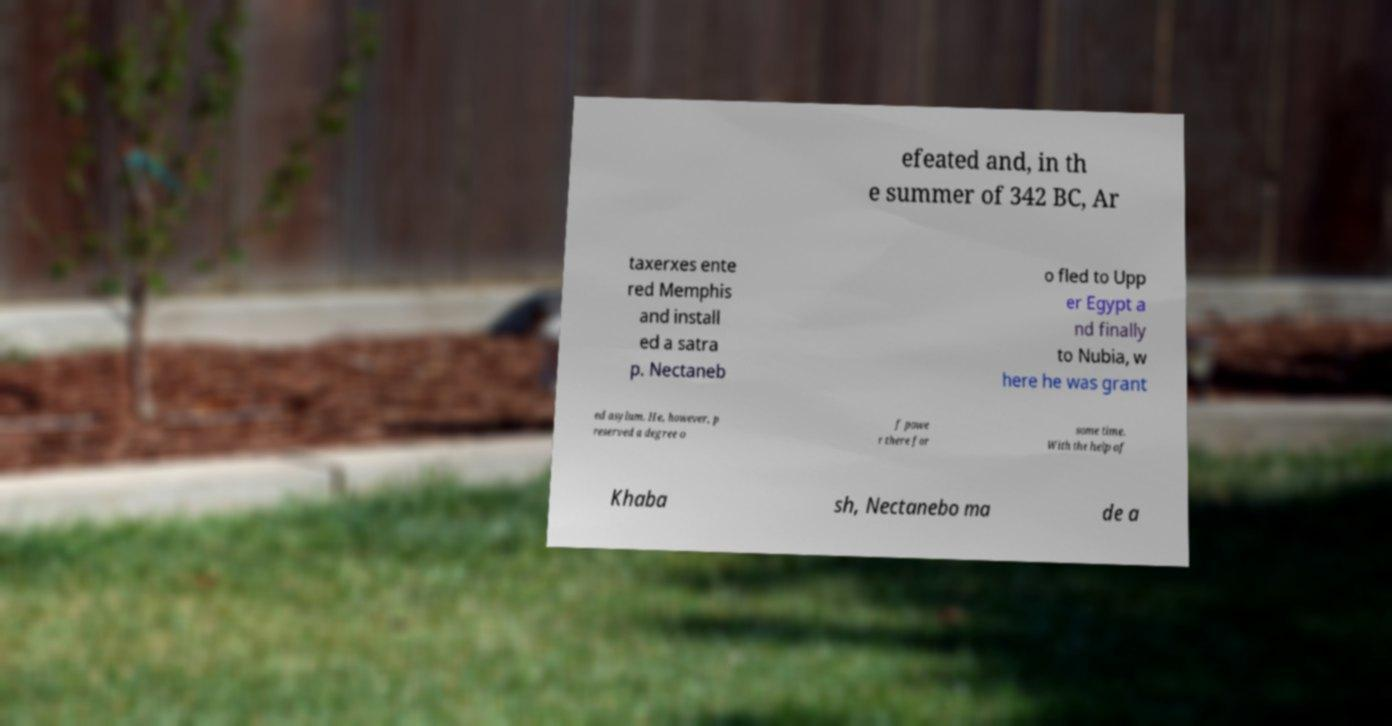For documentation purposes, I need the text within this image transcribed. Could you provide that? efeated and, in th e summer of 342 BC, Ar taxerxes ente red Memphis and install ed a satra p. Nectaneb o fled to Upp er Egypt a nd finally to Nubia, w here he was grant ed asylum. He, however, p reserved a degree o f powe r there for some time. With the help of Khaba sh, Nectanebo ma de a 